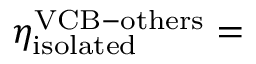Convert formula to latex. <formula><loc_0><loc_0><loc_500><loc_500>\eta _ { i s o l a t e d } ^ { V C B - o t h e r s } =</formula> 